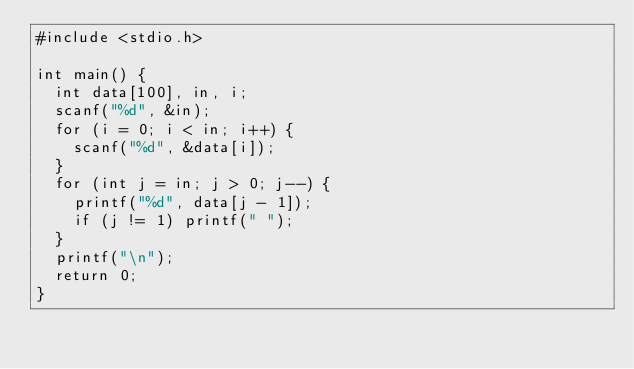Convert code to text. <code><loc_0><loc_0><loc_500><loc_500><_C_>#include <stdio.h>

int main() {
	int data[100], in, i;
	scanf("%d", &in);
	for (i = 0; i < in; i++) {
		scanf("%d", &data[i]);
	}
	for (int j = in; j > 0; j--) {
		printf("%d", data[j - 1]);
		if (j != 1) printf(" ");
	}
	printf("\n");
	return 0;
}
</code> 